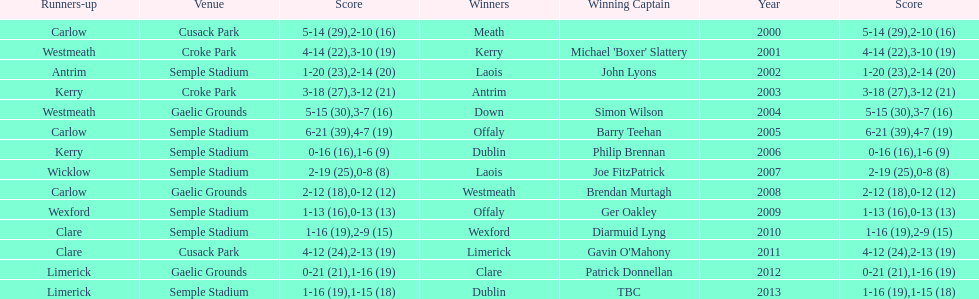Who scored the least? Wicklow. 